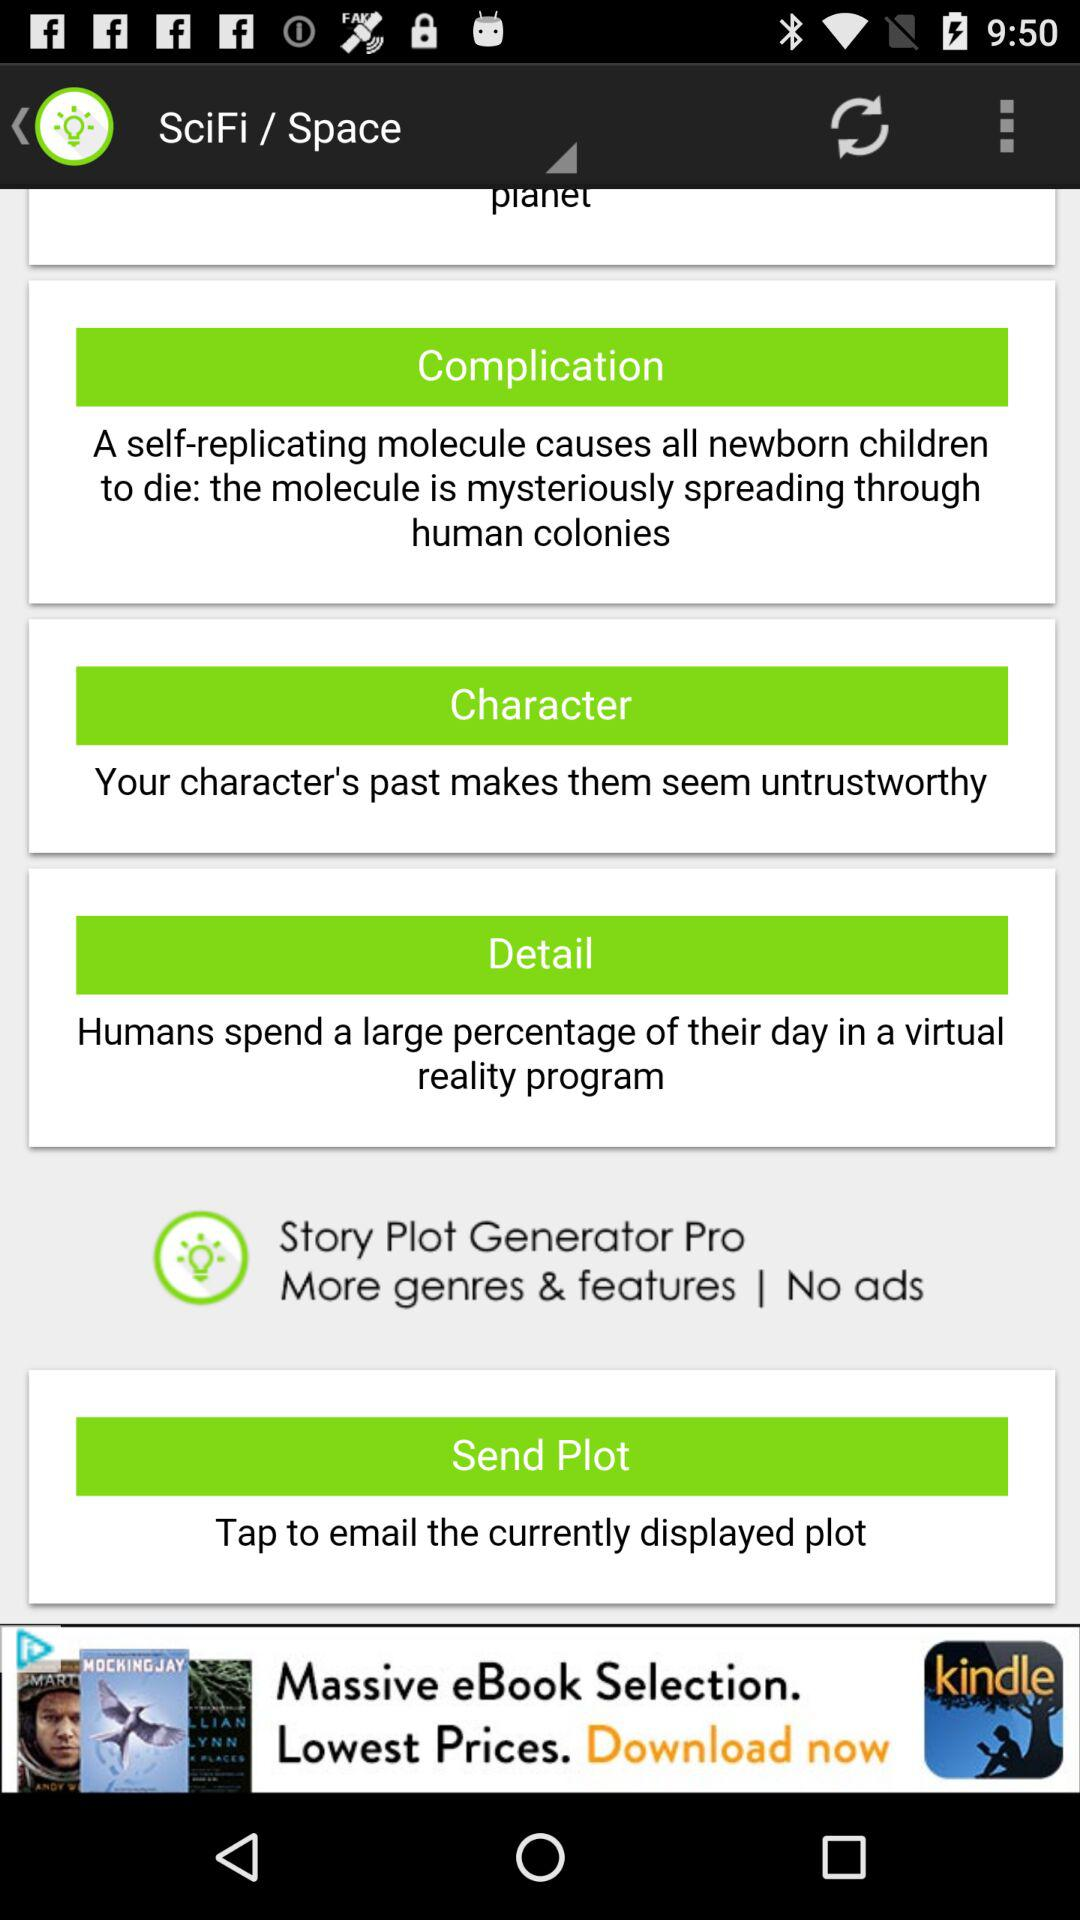What is the name of the application? The name of the application is "SciFi / Space". 